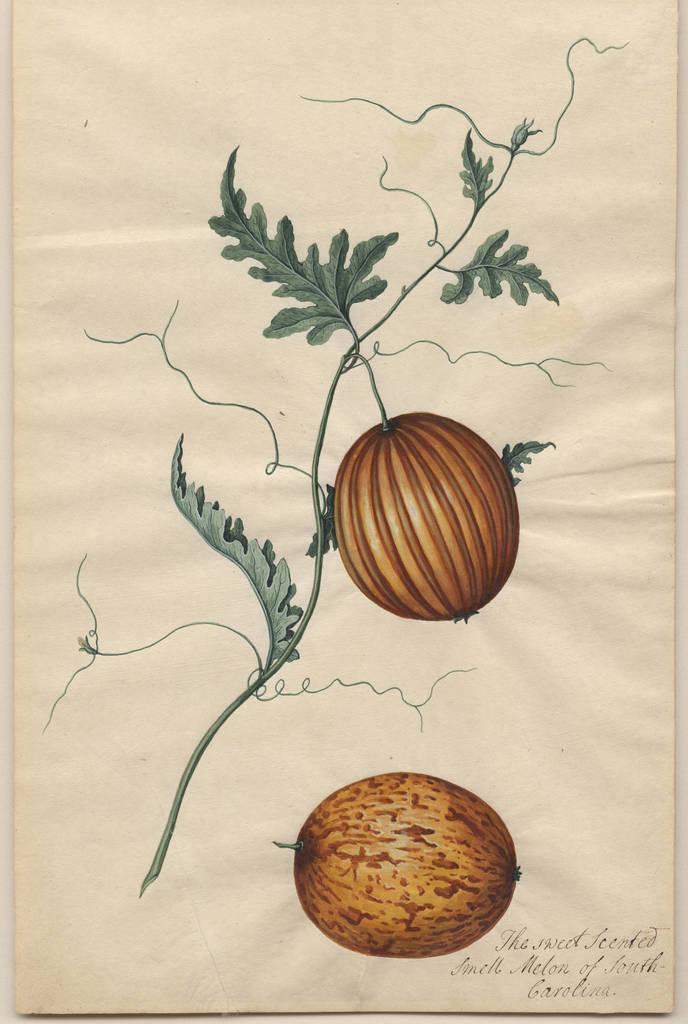What is depicted in the painting in the image? There is a painting of a plant with fruits in the image. What else can be seen at the bottom of the image? There is text on a paper at the bottom of the image. Is the painting framed in the image? The provided facts do not mention a frame, so we cannot determine if the painting is framed or not. Can you tell me how many plastic bottles are visible in the image? There is no mention of plastic bottles in the provided facts, so we cannot determine if any are visible in the image. 